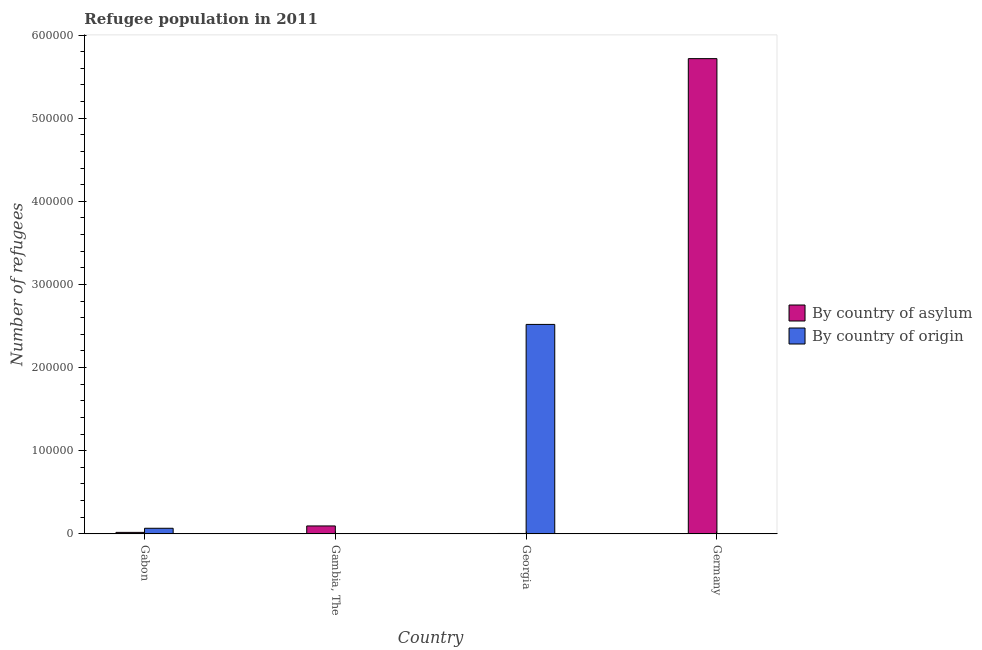How many different coloured bars are there?
Provide a succinct answer. 2. How many groups of bars are there?
Your answer should be compact. 4. Are the number of bars per tick equal to the number of legend labels?
Your answer should be compact. Yes. Are the number of bars on each tick of the X-axis equal?
Offer a terse response. Yes. How many bars are there on the 2nd tick from the right?
Ensure brevity in your answer.  2. What is the label of the 1st group of bars from the left?
Keep it short and to the point. Gabon. In how many cases, is the number of bars for a given country not equal to the number of legend labels?
Ensure brevity in your answer.  0. What is the number of refugees by country of asylum in Georgia?
Provide a succinct answer. 462. Across all countries, what is the maximum number of refugees by country of asylum?
Provide a succinct answer. 5.72e+05. Across all countries, what is the minimum number of refugees by country of origin?
Your answer should be very brief. 224. In which country was the number of refugees by country of origin maximum?
Offer a terse response. Georgia. In which country was the number of refugees by country of origin minimum?
Offer a terse response. Germany. What is the total number of refugees by country of asylum in the graph?
Provide a short and direct response. 5.83e+05. What is the difference between the number of refugees by country of asylum in Gambia, The and that in Georgia?
Provide a succinct answer. 9066. What is the difference between the number of refugees by country of asylum in Gambia, The and the number of refugees by country of origin in Germany?
Ensure brevity in your answer.  9304. What is the average number of refugees by country of asylum per country?
Offer a very short reply. 1.46e+05. What is the difference between the number of refugees by country of asylum and number of refugees by country of origin in Gambia, The?
Keep it short and to the point. 9270. What is the ratio of the number of refugees by country of origin in Gambia, The to that in Georgia?
Keep it short and to the point. 0. Is the number of refugees by country of asylum in Gambia, The less than that in Germany?
Offer a very short reply. Yes. What is the difference between the highest and the second highest number of refugees by country of origin?
Keep it short and to the point. 2.45e+05. What is the difference between the highest and the lowest number of refugees by country of origin?
Make the answer very short. 2.52e+05. What does the 1st bar from the left in Gambia, The represents?
Ensure brevity in your answer.  By country of asylum. What does the 1st bar from the right in Gambia, The represents?
Your answer should be very brief. By country of origin. How many bars are there?
Ensure brevity in your answer.  8. What is the difference between two consecutive major ticks on the Y-axis?
Your answer should be compact. 1.00e+05. Are the values on the major ticks of Y-axis written in scientific E-notation?
Provide a short and direct response. No. Does the graph contain grids?
Provide a short and direct response. No. What is the title of the graph?
Offer a terse response. Refugee population in 2011. What is the label or title of the Y-axis?
Your answer should be very brief. Number of refugees. What is the Number of refugees in By country of asylum in Gabon?
Your answer should be compact. 1773. What is the Number of refugees in By country of origin in Gabon?
Provide a short and direct response. 6720. What is the Number of refugees of By country of asylum in Gambia, The?
Keep it short and to the point. 9528. What is the Number of refugees in By country of origin in Gambia, The?
Offer a terse response. 258. What is the Number of refugees of By country of asylum in Georgia?
Ensure brevity in your answer.  462. What is the Number of refugees of By country of origin in Georgia?
Keep it short and to the point. 2.52e+05. What is the Number of refugees of By country of asylum in Germany?
Your answer should be compact. 5.72e+05. What is the Number of refugees of By country of origin in Germany?
Your response must be concise. 224. Across all countries, what is the maximum Number of refugees of By country of asylum?
Offer a terse response. 5.72e+05. Across all countries, what is the maximum Number of refugees in By country of origin?
Your response must be concise. 2.52e+05. Across all countries, what is the minimum Number of refugees of By country of asylum?
Your answer should be compact. 462. Across all countries, what is the minimum Number of refugees in By country of origin?
Give a very brief answer. 224. What is the total Number of refugees in By country of asylum in the graph?
Provide a succinct answer. 5.83e+05. What is the total Number of refugees of By country of origin in the graph?
Make the answer very short. 2.59e+05. What is the difference between the Number of refugees in By country of asylum in Gabon and that in Gambia, The?
Provide a succinct answer. -7755. What is the difference between the Number of refugees of By country of origin in Gabon and that in Gambia, The?
Keep it short and to the point. 6462. What is the difference between the Number of refugees of By country of asylum in Gabon and that in Georgia?
Your answer should be compact. 1311. What is the difference between the Number of refugees in By country of origin in Gabon and that in Georgia?
Make the answer very short. -2.45e+05. What is the difference between the Number of refugees of By country of asylum in Gabon and that in Germany?
Keep it short and to the point. -5.70e+05. What is the difference between the Number of refugees of By country of origin in Gabon and that in Germany?
Offer a terse response. 6496. What is the difference between the Number of refugees in By country of asylum in Gambia, The and that in Georgia?
Your answer should be compact. 9066. What is the difference between the Number of refugees of By country of origin in Gambia, The and that in Georgia?
Make the answer very short. -2.52e+05. What is the difference between the Number of refugees of By country of asylum in Gambia, The and that in Germany?
Keep it short and to the point. -5.62e+05. What is the difference between the Number of refugees in By country of origin in Gambia, The and that in Germany?
Offer a very short reply. 34. What is the difference between the Number of refugees in By country of asylum in Georgia and that in Germany?
Provide a succinct answer. -5.71e+05. What is the difference between the Number of refugees in By country of origin in Georgia and that in Germany?
Make the answer very short. 2.52e+05. What is the difference between the Number of refugees of By country of asylum in Gabon and the Number of refugees of By country of origin in Gambia, The?
Give a very brief answer. 1515. What is the difference between the Number of refugees in By country of asylum in Gabon and the Number of refugees in By country of origin in Georgia?
Make the answer very short. -2.50e+05. What is the difference between the Number of refugees in By country of asylum in Gabon and the Number of refugees in By country of origin in Germany?
Ensure brevity in your answer.  1549. What is the difference between the Number of refugees of By country of asylum in Gambia, The and the Number of refugees of By country of origin in Georgia?
Provide a short and direct response. -2.42e+05. What is the difference between the Number of refugees in By country of asylum in Gambia, The and the Number of refugees in By country of origin in Germany?
Provide a short and direct response. 9304. What is the difference between the Number of refugees of By country of asylum in Georgia and the Number of refugees of By country of origin in Germany?
Keep it short and to the point. 238. What is the average Number of refugees in By country of asylum per country?
Make the answer very short. 1.46e+05. What is the average Number of refugees in By country of origin per country?
Provide a succinct answer. 6.48e+04. What is the difference between the Number of refugees of By country of asylum and Number of refugees of By country of origin in Gabon?
Your response must be concise. -4947. What is the difference between the Number of refugees in By country of asylum and Number of refugees in By country of origin in Gambia, The?
Your answer should be very brief. 9270. What is the difference between the Number of refugees of By country of asylum and Number of refugees of By country of origin in Georgia?
Make the answer very short. -2.51e+05. What is the difference between the Number of refugees in By country of asylum and Number of refugees in By country of origin in Germany?
Your answer should be very brief. 5.71e+05. What is the ratio of the Number of refugees in By country of asylum in Gabon to that in Gambia, The?
Offer a terse response. 0.19. What is the ratio of the Number of refugees in By country of origin in Gabon to that in Gambia, The?
Your answer should be very brief. 26.05. What is the ratio of the Number of refugees in By country of asylum in Gabon to that in Georgia?
Provide a short and direct response. 3.84. What is the ratio of the Number of refugees of By country of origin in Gabon to that in Georgia?
Offer a terse response. 0.03. What is the ratio of the Number of refugees of By country of asylum in Gabon to that in Germany?
Keep it short and to the point. 0. What is the ratio of the Number of refugees of By country of asylum in Gambia, The to that in Georgia?
Offer a terse response. 20.62. What is the ratio of the Number of refugees of By country of asylum in Gambia, The to that in Germany?
Ensure brevity in your answer.  0.02. What is the ratio of the Number of refugees of By country of origin in Gambia, The to that in Germany?
Provide a short and direct response. 1.15. What is the ratio of the Number of refugees of By country of asylum in Georgia to that in Germany?
Your response must be concise. 0. What is the ratio of the Number of refugees in By country of origin in Georgia to that in Germany?
Keep it short and to the point. 1124.79. What is the difference between the highest and the second highest Number of refugees of By country of asylum?
Your answer should be compact. 5.62e+05. What is the difference between the highest and the second highest Number of refugees of By country of origin?
Your answer should be very brief. 2.45e+05. What is the difference between the highest and the lowest Number of refugees of By country of asylum?
Your response must be concise. 5.71e+05. What is the difference between the highest and the lowest Number of refugees in By country of origin?
Your answer should be compact. 2.52e+05. 